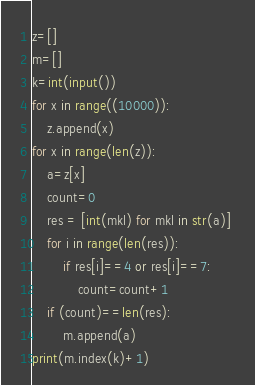<code> <loc_0><loc_0><loc_500><loc_500><_Python_>z=[]
m=[]
k=int(input())
for x in range((10000)):
    z.append(x)
for x in range(len(z)):
    a=z[x]
    count=0
    res = [int(mkl) for mkl in str(a)] 
    for i in range(len(res)):
        if res[i]==4 or res[i]==7:
            count=count+1
    if (count)==len(res):
        m.append(a)
print(m.index(k)+1)
</code> 